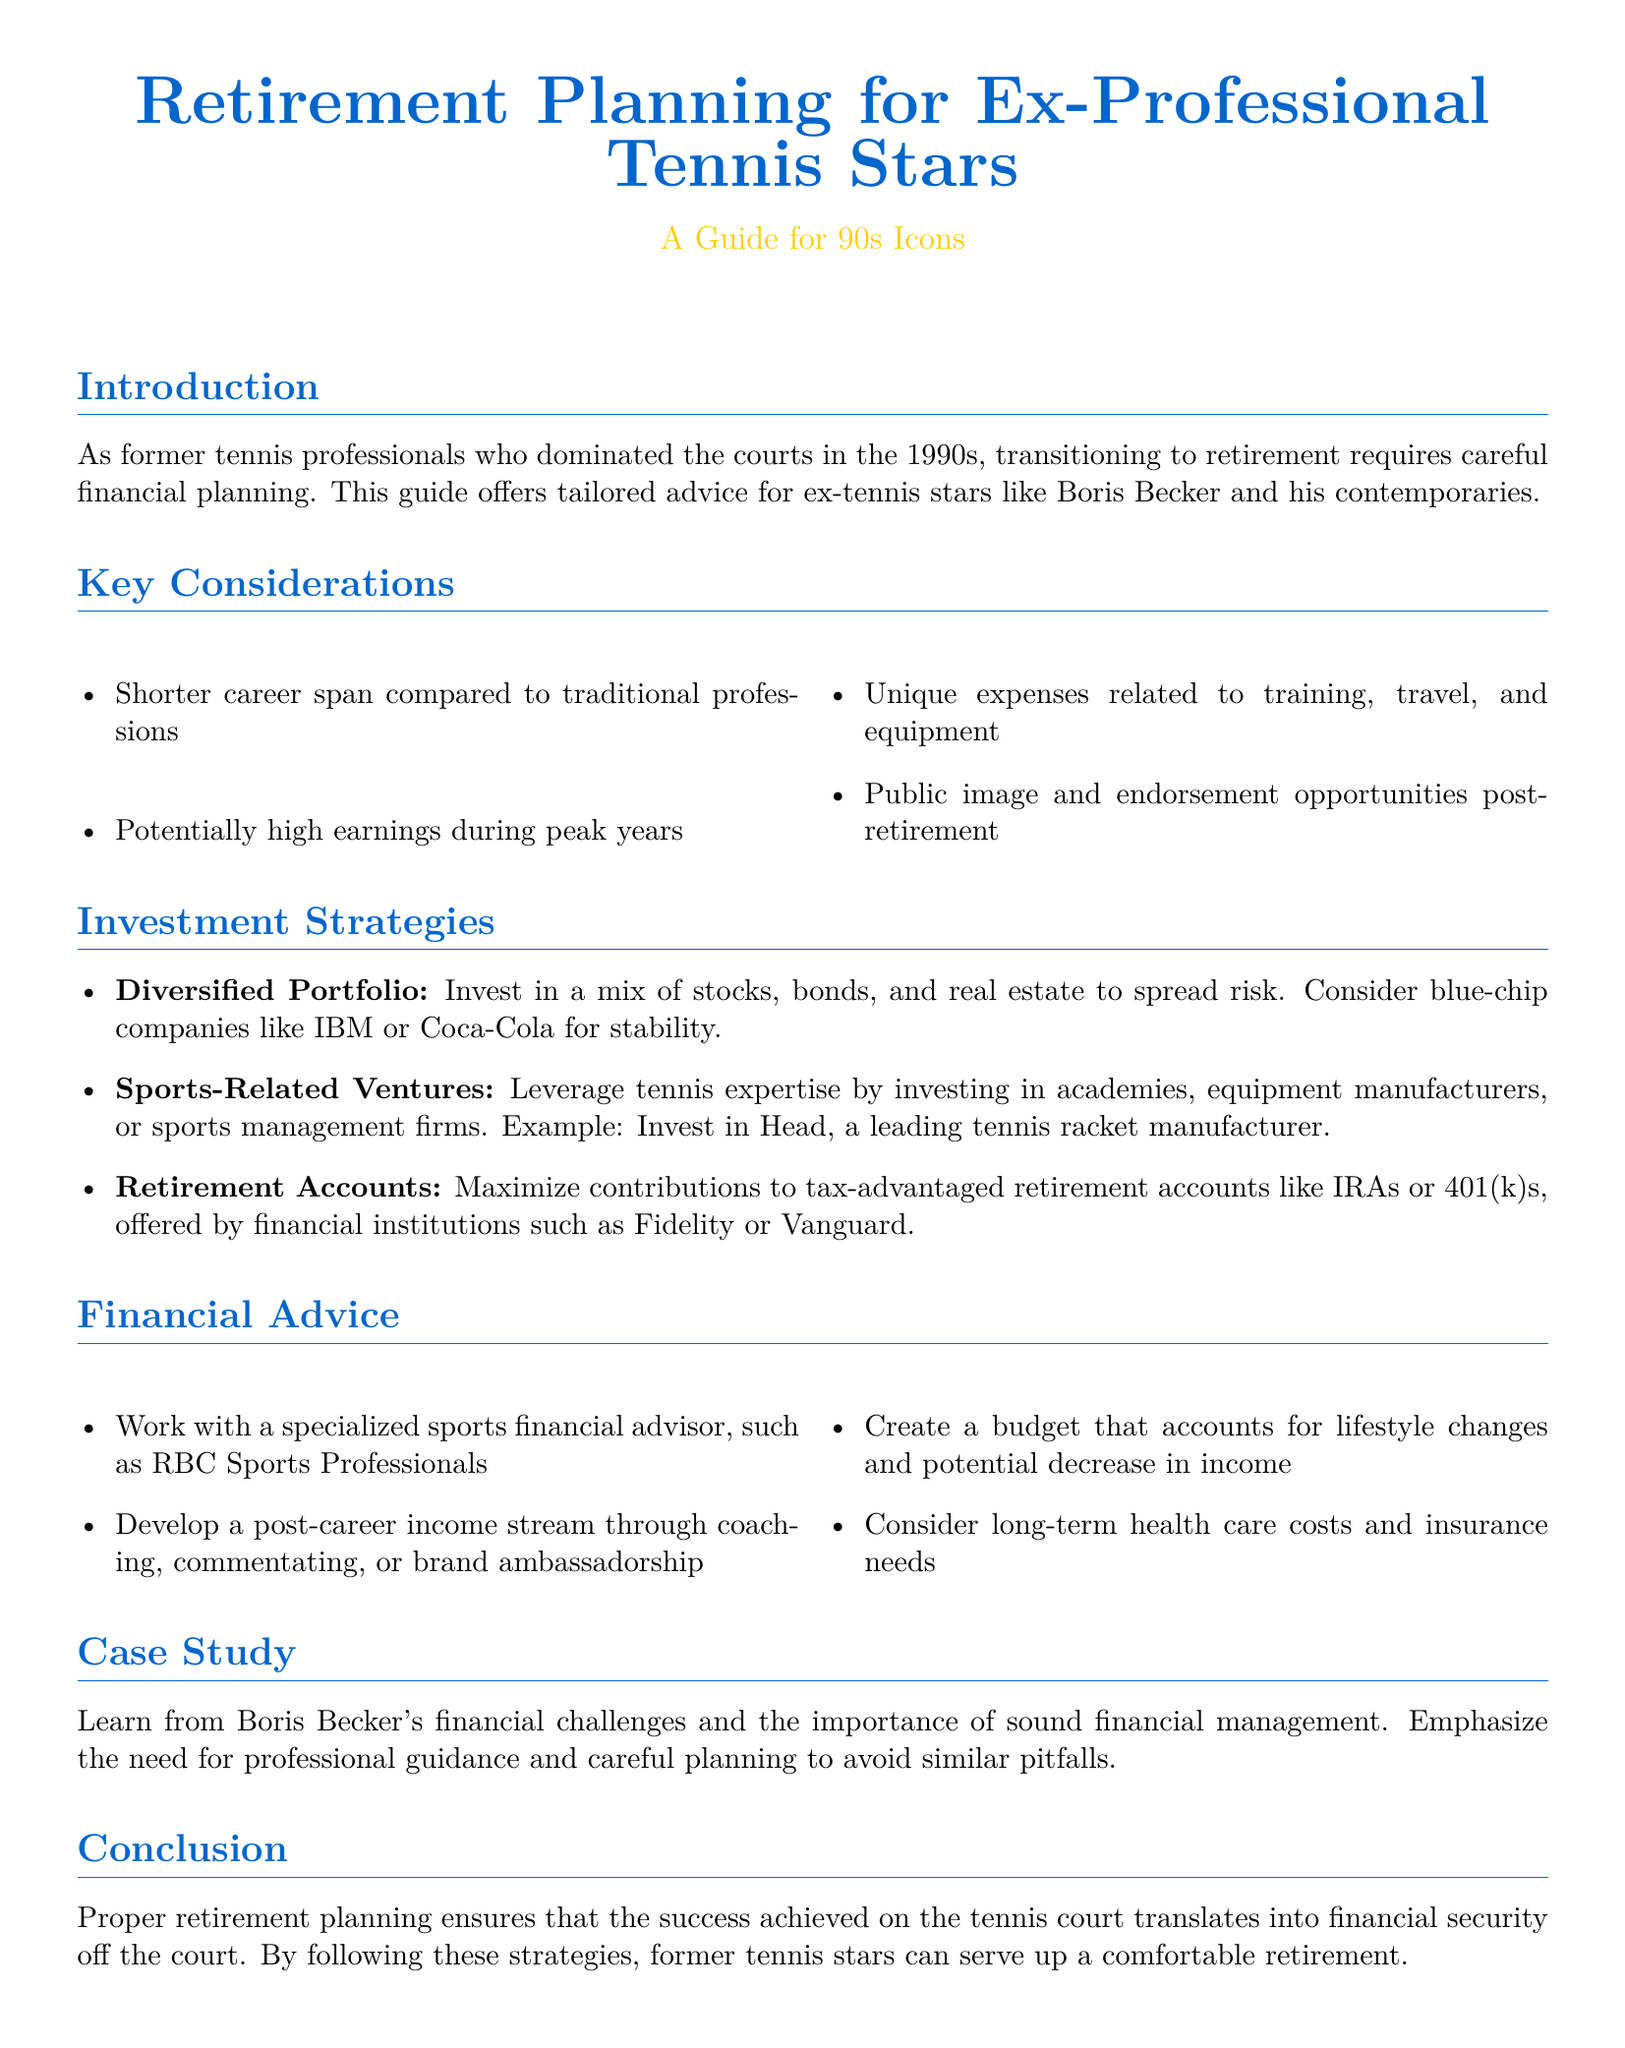What is the title of the document? The title of the document is prominently stated at the beginning of the document.
Answer: Retirement Planning for Ex-Professional Tennis Stars Who is the target audience of this guide? The document specifically mentions its intended audience within the introductory section.
Answer: Ex-professional tennis stars What financial institution is suggested for retirement accounts? The section on investment strategies names financial institutions suitable for retirement accounts.
Answer: Fidelity or Vanguard What is one potential source of post-career income mentioned? In the financial advice section, various sources of post-career income are listed.
Answer: Coaching Which sports-related business type is suggested for investment? The investment strategies section discusses leveraging tennis expertise through specific business types.
Answer: Academies What was the example given for a sports-related venture investment? An example is provided in the investment strategies section to illustrate the type of venture suggested for investment.
Answer: Head What is the advised approach to financial planning for ex-athletes? The introduction lays out a broad approach to financial planning tailored to the audience.
Answer: Careful financial planning What is one key financial consideration outlined in the document? The key considerations section highlights specific financial aspects that ex-athletes should keep in mind.
Answer: Unique expenses related to training, travel, and equipment What does the case study in the document focus on? The case study section points out the relevance of learning from a specific individual's experiences.
Answer: Boris Becker's financial challenges 